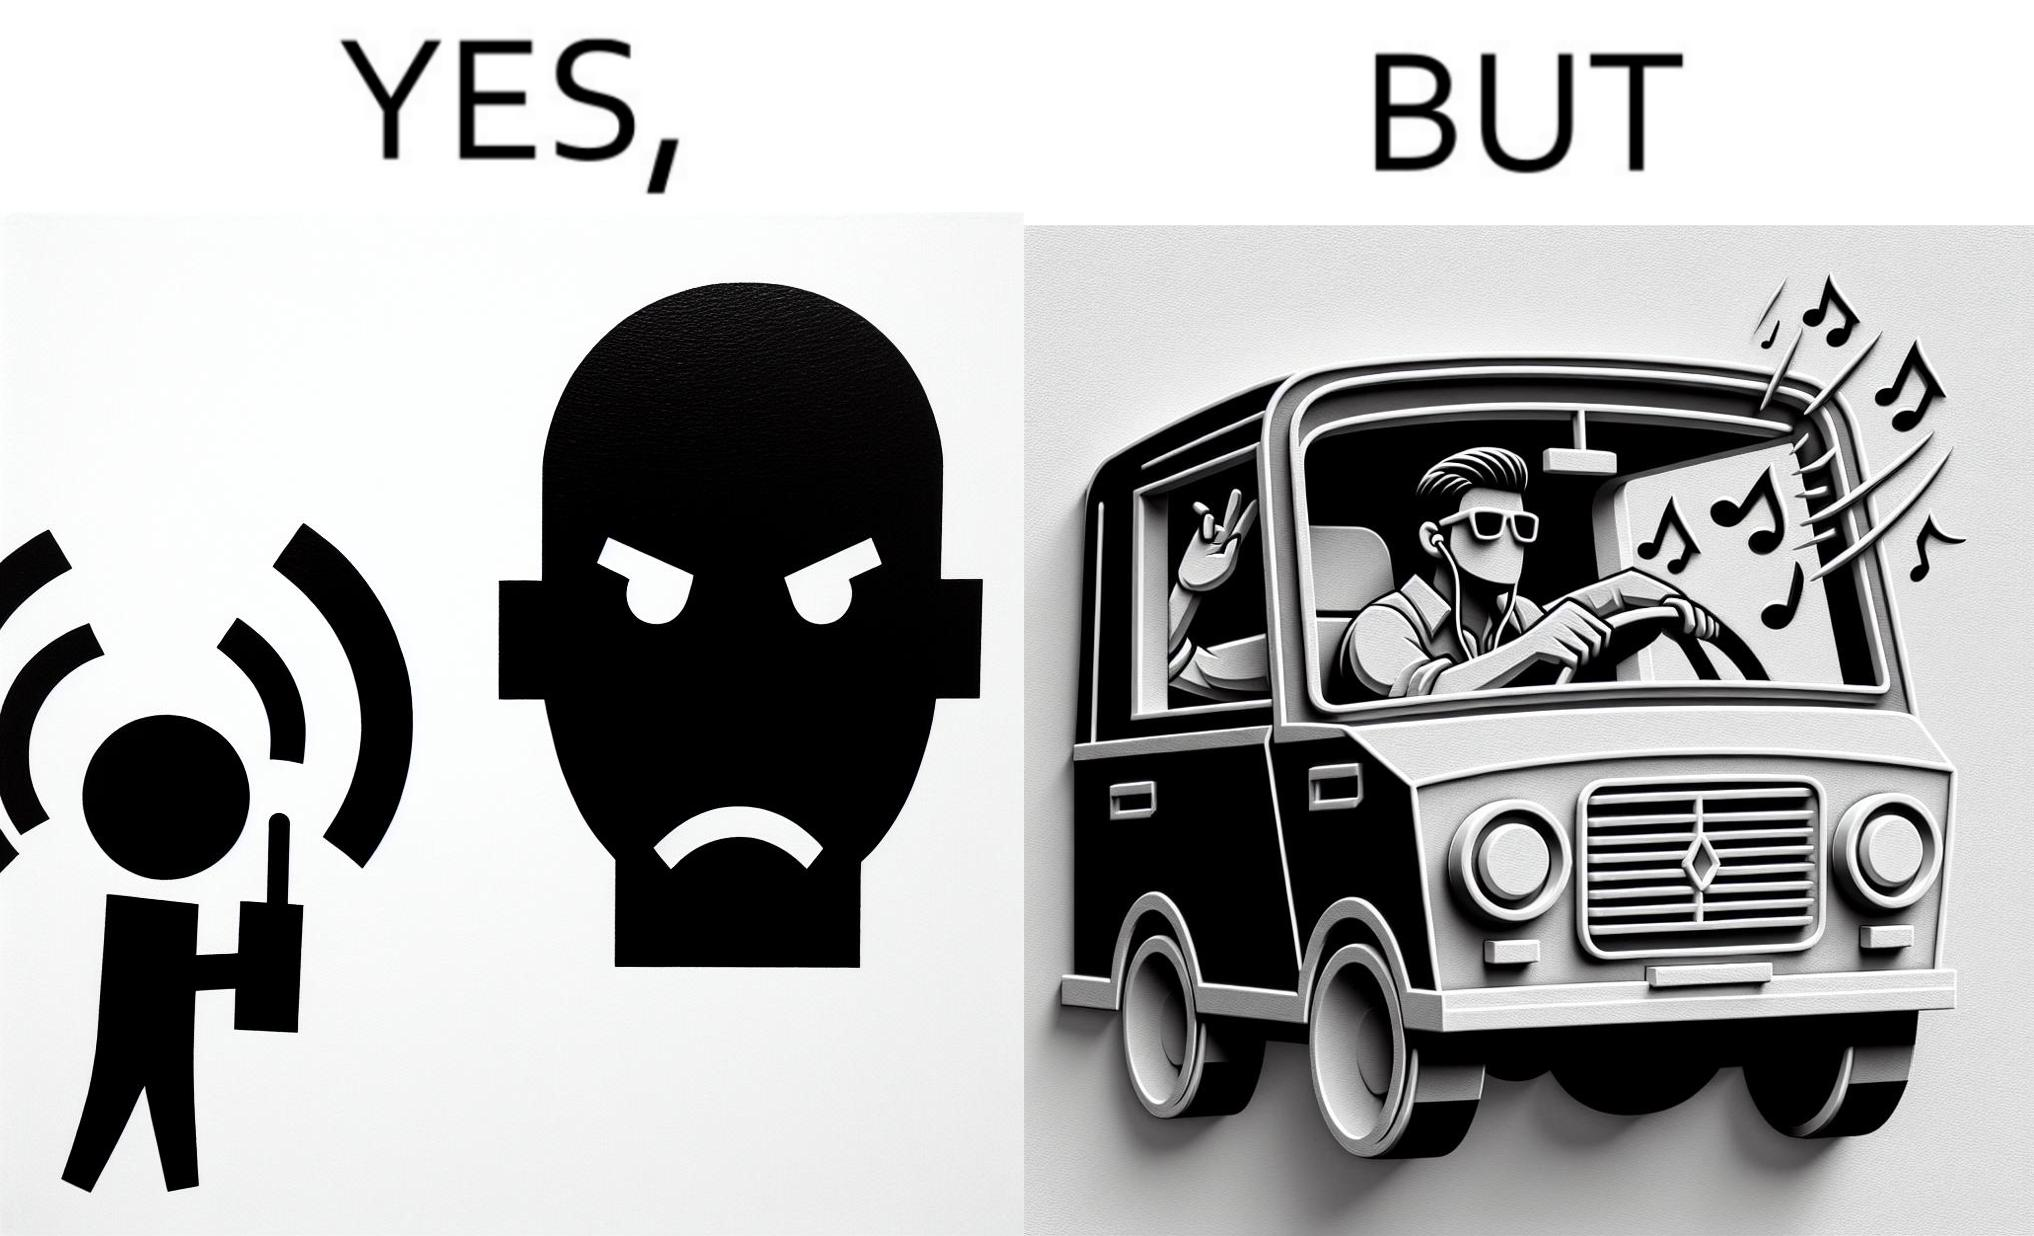Would you classify this image as satirical? Yes, this image is satirical. 